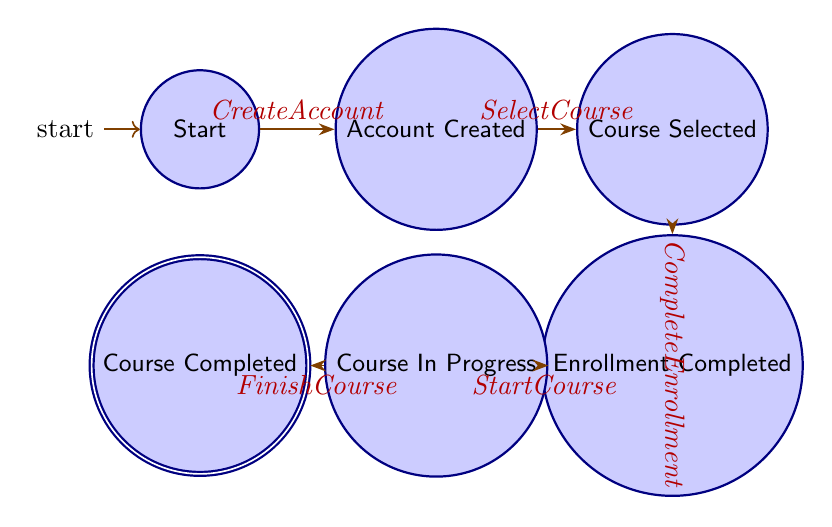What is the starting state of the process? The diagram indicates that the process starts at the node labeled 'Start', which is the initial state.
Answer: Start How many states are in the diagram? The diagram shows a total of six states: Start, Account Created, Course Selected, Enrollment Completed, Course In Progress, and Course Completed.
Answer: 6 What event leads from 'Account Created' to 'Course Selected'? The transition from 'Account Created' to 'Course Selected' occurs when the event 'SelectCourse' is triggered.
Answer: SelectCourse What is the final state in the process? The final state, where the process concludes, is indicated as 'Course Completed'.
Answer: Course Completed Which transition occurs after 'Enrollment Completed'? After 'Enrollment Completed', the next transition is triggered by the event 'StartCourse' leading to the 'Course In Progress' state.
Answer: StartCourse What is the relationship between 'Course In Progress' and 'Course Completed'? The relationship between these two states is that 'Course In Progress' transitions to 'Course Completed' through the event 'FinishCourse'.
Answer: FinishCourse How many transitions are present in the diagram? There are five transitions connecting the states in the process, as shown by the arrows indicating the flow from one state to another.
Answer: 5 Which state follows the 'Course Selected' state? Following the 'Course Selected' state, the process moves to the 'Enrollment Completed' state upon the occurrence of the event 'CompleteEnrollment'.
Answer: Enrollment Completed What event leads to the 'Enrollment Completed' state? The event that leads to the 'Enrollment Completed' state is 'CompleteEnrollment', which follows 'Course Selected'.
Answer: CompleteEnrollment 